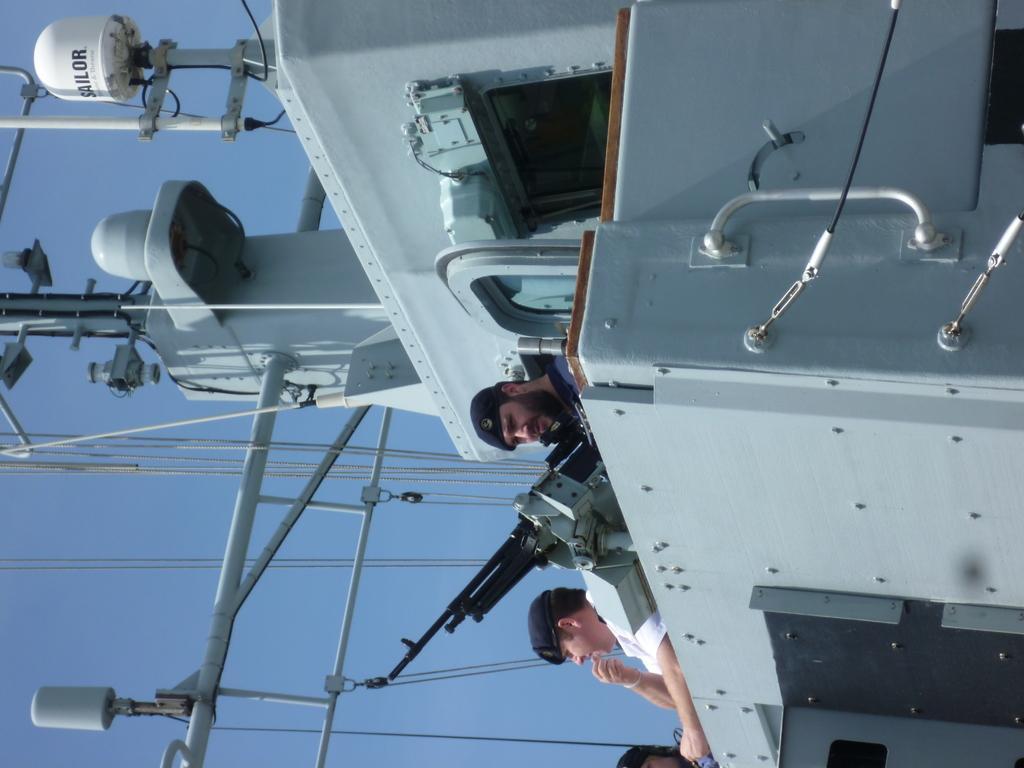Could you give a brief overview of what you see in this image? In this picture we can see a ship, there are three persons and a gun in the middle, on the left side we can see wires, there is the sky in the background. 